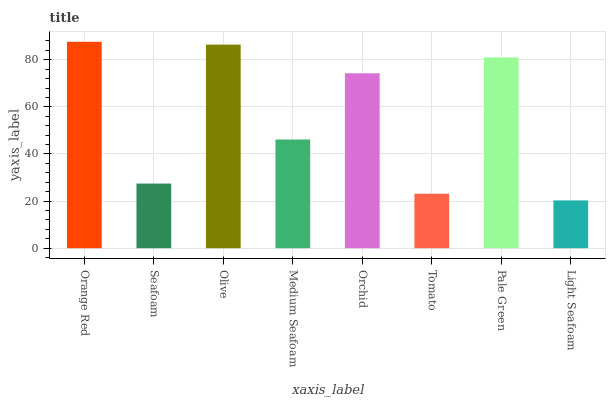Is Light Seafoam the minimum?
Answer yes or no. Yes. Is Orange Red the maximum?
Answer yes or no. Yes. Is Seafoam the minimum?
Answer yes or no. No. Is Seafoam the maximum?
Answer yes or no. No. Is Orange Red greater than Seafoam?
Answer yes or no. Yes. Is Seafoam less than Orange Red?
Answer yes or no. Yes. Is Seafoam greater than Orange Red?
Answer yes or no. No. Is Orange Red less than Seafoam?
Answer yes or no. No. Is Orchid the high median?
Answer yes or no. Yes. Is Medium Seafoam the low median?
Answer yes or no. Yes. Is Tomato the high median?
Answer yes or no. No. Is Olive the low median?
Answer yes or no. No. 